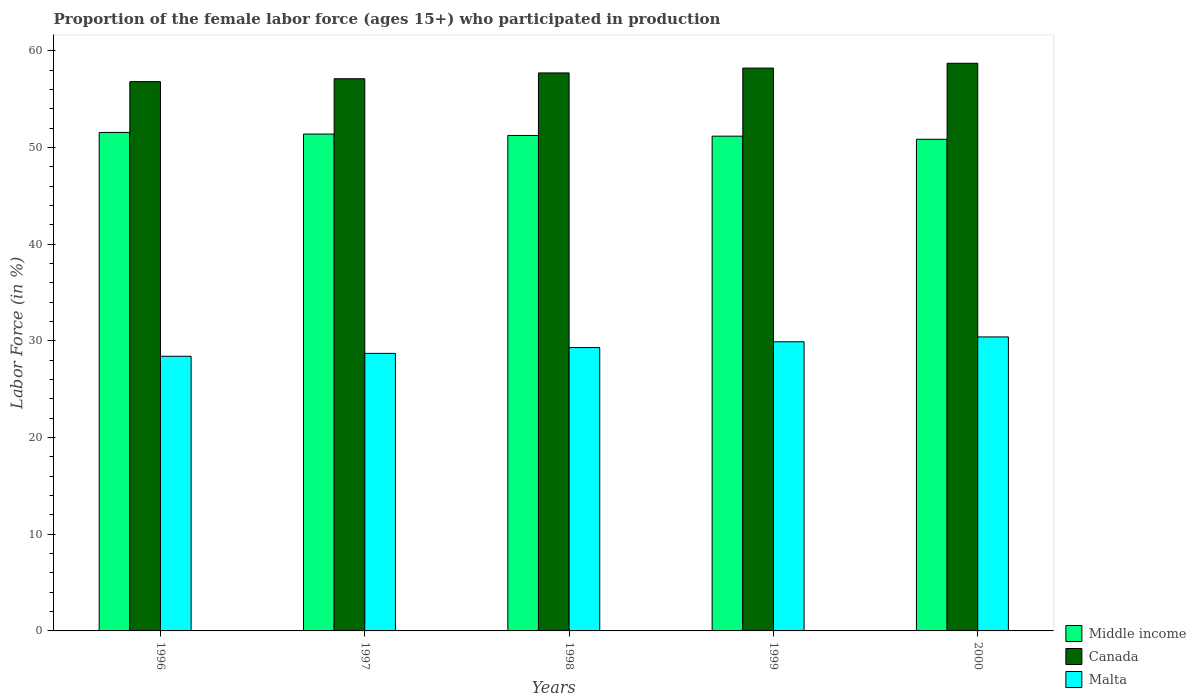Are the number of bars on each tick of the X-axis equal?
Offer a very short reply. Yes. How many bars are there on the 5th tick from the left?
Provide a succinct answer. 3. What is the proportion of the female labor force who participated in production in Middle income in 1997?
Ensure brevity in your answer.  51.38. Across all years, what is the maximum proportion of the female labor force who participated in production in Middle income?
Your answer should be very brief. 51.55. Across all years, what is the minimum proportion of the female labor force who participated in production in Middle income?
Your answer should be very brief. 50.84. In which year was the proportion of the female labor force who participated in production in Malta minimum?
Ensure brevity in your answer.  1996. What is the total proportion of the female labor force who participated in production in Malta in the graph?
Make the answer very short. 146.7. What is the difference between the proportion of the female labor force who participated in production in Canada in 1996 and that in 1999?
Offer a terse response. -1.4. What is the difference between the proportion of the female labor force who participated in production in Middle income in 1997 and the proportion of the female labor force who participated in production in Malta in 1999?
Ensure brevity in your answer.  21.48. What is the average proportion of the female labor force who participated in production in Middle income per year?
Keep it short and to the point. 51.23. In the year 1998, what is the difference between the proportion of the female labor force who participated in production in Middle income and proportion of the female labor force who participated in production in Canada?
Your response must be concise. -6.47. In how many years, is the proportion of the female labor force who participated in production in Canada greater than 36 %?
Ensure brevity in your answer.  5. What is the ratio of the proportion of the female labor force who participated in production in Malta in 1998 to that in 1999?
Ensure brevity in your answer.  0.98. Is the proportion of the female labor force who participated in production in Canada in 1996 less than that in 1998?
Offer a very short reply. Yes. What is the difference between the highest and the second highest proportion of the female labor force who participated in production in Middle income?
Make the answer very short. 0.17. What is the difference between the highest and the lowest proportion of the female labor force who participated in production in Middle income?
Your answer should be very brief. 0.71. In how many years, is the proportion of the female labor force who participated in production in Middle income greater than the average proportion of the female labor force who participated in production in Middle income taken over all years?
Give a very brief answer. 3. What does the 1st bar from the left in 1997 represents?
Your response must be concise. Middle income. What does the 1st bar from the right in 1999 represents?
Your answer should be compact. Malta. How many bars are there?
Offer a terse response. 15. Are the values on the major ticks of Y-axis written in scientific E-notation?
Give a very brief answer. No. Does the graph contain grids?
Offer a very short reply. No. What is the title of the graph?
Your answer should be compact. Proportion of the female labor force (ages 15+) who participated in production. Does "Montenegro" appear as one of the legend labels in the graph?
Keep it short and to the point. No. What is the Labor Force (in %) of Middle income in 1996?
Give a very brief answer. 51.55. What is the Labor Force (in %) of Canada in 1996?
Provide a short and direct response. 56.8. What is the Labor Force (in %) in Malta in 1996?
Give a very brief answer. 28.4. What is the Labor Force (in %) of Middle income in 1997?
Your answer should be compact. 51.38. What is the Labor Force (in %) in Canada in 1997?
Make the answer very short. 57.1. What is the Labor Force (in %) of Malta in 1997?
Your answer should be compact. 28.7. What is the Labor Force (in %) in Middle income in 1998?
Keep it short and to the point. 51.23. What is the Labor Force (in %) of Canada in 1998?
Provide a short and direct response. 57.7. What is the Labor Force (in %) of Malta in 1998?
Make the answer very short. 29.3. What is the Labor Force (in %) in Middle income in 1999?
Ensure brevity in your answer.  51.16. What is the Labor Force (in %) in Canada in 1999?
Give a very brief answer. 58.2. What is the Labor Force (in %) in Malta in 1999?
Offer a very short reply. 29.9. What is the Labor Force (in %) in Middle income in 2000?
Make the answer very short. 50.84. What is the Labor Force (in %) of Canada in 2000?
Provide a short and direct response. 58.7. What is the Labor Force (in %) of Malta in 2000?
Give a very brief answer. 30.4. Across all years, what is the maximum Labor Force (in %) of Middle income?
Your answer should be very brief. 51.55. Across all years, what is the maximum Labor Force (in %) in Canada?
Offer a terse response. 58.7. Across all years, what is the maximum Labor Force (in %) in Malta?
Provide a succinct answer. 30.4. Across all years, what is the minimum Labor Force (in %) of Middle income?
Offer a terse response. 50.84. Across all years, what is the minimum Labor Force (in %) of Canada?
Ensure brevity in your answer.  56.8. Across all years, what is the minimum Labor Force (in %) in Malta?
Offer a very short reply. 28.4. What is the total Labor Force (in %) in Middle income in the graph?
Make the answer very short. 256.16. What is the total Labor Force (in %) in Canada in the graph?
Your response must be concise. 288.5. What is the total Labor Force (in %) of Malta in the graph?
Give a very brief answer. 146.7. What is the difference between the Labor Force (in %) in Middle income in 1996 and that in 1997?
Offer a very short reply. 0.17. What is the difference between the Labor Force (in %) in Canada in 1996 and that in 1997?
Provide a short and direct response. -0.3. What is the difference between the Labor Force (in %) in Malta in 1996 and that in 1997?
Offer a terse response. -0.3. What is the difference between the Labor Force (in %) of Middle income in 1996 and that in 1998?
Offer a terse response. 0.31. What is the difference between the Labor Force (in %) in Canada in 1996 and that in 1998?
Your response must be concise. -0.9. What is the difference between the Labor Force (in %) of Middle income in 1996 and that in 1999?
Your answer should be very brief. 0.39. What is the difference between the Labor Force (in %) in Malta in 1996 and that in 1999?
Offer a terse response. -1.5. What is the difference between the Labor Force (in %) in Middle income in 1996 and that in 2000?
Give a very brief answer. 0.71. What is the difference between the Labor Force (in %) of Canada in 1996 and that in 2000?
Keep it short and to the point. -1.9. What is the difference between the Labor Force (in %) of Malta in 1996 and that in 2000?
Your response must be concise. -2. What is the difference between the Labor Force (in %) of Middle income in 1997 and that in 1998?
Make the answer very short. 0.15. What is the difference between the Labor Force (in %) in Malta in 1997 and that in 1998?
Your answer should be very brief. -0.6. What is the difference between the Labor Force (in %) of Middle income in 1997 and that in 1999?
Provide a succinct answer. 0.22. What is the difference between the Labor Force (in %) of Middle income in 1997 and that in 2000?
Your answer should be compact. 0.54. What is the difference between the Labor Force (in %) in Canada in 1997 and that in 2000?
Your answer should be very brief. -1.6. What is the difference between the Labor Force (in %) of Middle income in 1998 and that in 1999?
Ensure brevity in your answer.  0.07. What is the difference between the Labor Force (in %) in Canada in 1998 and that in 1999?
Your response must be concise. -0.5. What is the difference between the Labor Force (in %) of Malta in 1998 and that in 1999?
Make the answer very short. -0.6. What is the difference between the Labor Force (in %) in Middle income in 1998 and that in 2000?
Your response must be concise. 0.39. What is the difference between the Labor Force (in %) in Canada in 1998 and that in 2000?
Offer a terse response. -1. What is the difference between the Labor Force (in %) in Middle income in 1999 and that in 2000?
Your answer should be very brief. 0.32. What is the difference between the Labor Force (in %) in Canada in 1999 and that in 2000?
Give a very brief answer. -0.5. What is the difference between the Labor Force (in %) of Malta in 1999 and that in 2000?
Your answer should be very brief. -0.5. What is the difference between the Labor Force (in %) in Middle income in 1996 and the Labor Force (in %) in Canada in 1997?
Your answer should be very brief. -5.55. What is the difference between the Labor Force (in %) of Middle income in 1996 and the Labor Force (in %) of Malta in 1997?
Give a very brief answer. 22.85. What is the difference between the Labor Force (in %) of Canada in 1996 and the Labor Force (in %) of Malta in 1997?
Provide a short and direct response. 28.1. What is the difference between the Labor Force (in %) of Middle income in 1996 and the Labor Force (in %) of Canada in 1998?
Your answer should be compact. -6.15. What is the difference between the Labor Force (in %) of Middle income in 1996 and the Labor Force (in %) of Malta in 1998?
Your answer should be compact. 22.25. What is the difference between the Labor Force (in %) of Canada in 1996 and the Labor Force (in %) of Malta in 1998?
Keep it short and to the point. 27.5. What is the difference between the Labor Force (in %) in Middle income in 1996 and the Labor Force (in %) in Canada in 1999?
Provide a succinct answer. -6.65. What is the difference between the Labor Force (in %) of Middle income in 1996 and the Labor Force (in %) of Malta in 1999?
Make the answer very short. 21.65. What is the difference between the Labor Force (in %) of Canada in 1996 and the Labor Force (in %) of Malta in 1999?
Keep it short and to the point. 26.9. What is the difference between the Labor Force (in %) in Middle income in 1996 and the Labor Force (in %) in Canada in 2000?
Your response must be concise. -7.15. What is the difference between the Labor Force (in %) in Middle income in 1996 and the Labor Force (in %) in Malta in 2000?
Ensure brevity in your answer.  21.15. What is the difference between the Labor Force (in %) in Canada in 1996 and the Labor Force (in %) in Malta in 2000?
Make the answer very short. 26.4. What is the difference between the Labor Force (in %) in Middle income in 1997 and the Labor Force (in %) in Canada in 1998?
Your response must be concise. -6.32. What is the difference between the Labor Force (in %) of Middle income in 1997 and the Labor Force (in %) of Malta in 1998?
Your answer should be compact. 22.08. What is the difference between the Labor Force (in %) in Canada in 1997 and the Labor Force (in %) in Malta in 1998?
Offer a terse response. 27.8. What is the difference between the Labor Force (in %) in Middle income in 1997 and the Labor Force (in %) in Canada in 1999?
Your answer should be compact. -6.82. What is the difference between the Labor Force (in %) in Middle income in 1997 and the Labor Force (in %) in Malta in 1999?
Offer a terse response. 21.48. What is the difference between the Labor Force (in %) in Canada in 1997 and the Labor Force (in %) in Malta in 1999?
Your answer should be compact. 27.2. What is the difference between the Labor Force (in %) of Middle income in 1997 and the Labor Force (in %) of Canada in 2000?
Make the answer very short. -7.32. What is the difference between the Labor Force (in %) of Middle income in 1997 and the Labor Force (in %) of Malta in 2000?
Your answer should be very brief. 20.98. What is the difference between the Labor Force (in %) of Canada in 1997 and the Labor Force (in %) of Malta in 2000?
Provide a succinct answer. 26.7. What is the difference between the Labor Force (in %) of Middle income in 1998 and the Labor Force (in %) of Canada in 1999?
Offer a terse response. -6.97. What is the difference between the Labor Force (in %) in Middle income in 1998 and the Labor Force (in %) in Malta in 1999?
Keep it short and to the point. 21.33. What is the difference between the Labor Force (in %) in Canada in 1998 and the Labor Force (in %) in Malta in 1999?
Your response must be concise. 27.8. What is the difference between the Labor Force (in %) of Middle income in 1998 and the Labor Force (in %) of Canada in 2000?
Provide a succinct answer. -7.47. What is the difference between the Labor Force (in %) of Middle income in 1998 and the Labor Force (in %) of Malta in 2000?
Offer a very short reply. 20.83. What is the difference between the Labor Force (in %) of Canada in 1998 and the Labor Force (in %) of Malta in 2000?
Offer a terse response. 27.3. What is the difference between the Labor Force (in %) of Middle income in 1999 and the Labor Force (in %) of Canada in 2000?
Make the answer very short. -7.54. What is the difference between the Labor Force (in %) in Middle income in 1999 and the Labor Force (in %) in Malta in 2000?
Provide a succinct answer. 20.76. What is the difference between the Labor Force (in %) of Canada in 1999 and the Labor Force (in %) of Malta in 2000?
Your answer should be very brief. 27.8. What is the average Labor Force (in %) of Middle income per year?
Provide a succinct answer. 51.23. What is the average Labor Force (in %) of Canada per year?
Make the answer very short. 57.7. What is the average Labor Force (in %) in Malta per year?
Provide a short and direct response. 29.34. In the year 1996, what is the difference between the Labor Force (in %) in Middle income and Labor Force (in %) in Canada?
Give a very brief answer. -5.25. In the year 1996, what is the difference between the Labor Force (in %) of Middle income and Labor Force (in %) of Malta?
Make the answer very short. 23.15. In the year 1996, what is the difference between the Labor Force (in %) of Canada and Labor Force (in %) of Malta?
Your answer should be compact. 28.4. In the year 1997, what is the difference between the Labor Force (in %) in Middle income and Labor Force (in %) in Canada?
Provide a succinct answer. -5.72. In the year 1997, what is the difference between the Labor Force (in %) in Middle income and Labor Force (in %) in Malta?
Make the answer very short. 22.68. In the year 1997, what is the difference between the Labor Force (in %) of Canada and Labor Force (in %) of Malta?
Make the answer very short. 28.4. In the year 1998, what is the difference between the Labor Force (in %) of Middle income and Labor Force (in %) of Canada?
Offer a terse response. -6.47. In the year 1998, what is the difference between the Labor Force (in %) of Middle income and Labor Force (in %) of Malta?
Your answer should be compact. 21.93. In the year 1998, what is the difference between the Labor Force (in %) in Canada and Labor Force (in %) in Malta?
Provide a succinct answer. 28.4. In the year 1999, what is the difference between the Labor Force (in %) in Middle income and Labor Force (in %) in Canada?
Offer a very short reply. -7.04. In the year 1999, what is the difference between the Labor Force (in %) in Middle income and Labor Force (in %) in Malta?
Provide a succinct answer. 21.26. In the year 1999, what is the difference between the Labor Force (in %) in Canada and Labor Force (in %) in Malta?
Keep it short and to the point. 28.3. In the year 2000, what is the difference between the Labor Force (in %) in Middle income and Labor Force (in %) in Canada?
Your answer should be compact. -7.86. In the year 2000, what is the difference between the Labor Force (in %) of Middle income and Labor Force (in %) of Malta?
Your answer should be very brief. 20.44. In the year 2000, what is the difference between the Labor Force (in %) of Canada and Labor Force (in %) of Malta?
Keep it short and to the point. 28.3. What is the ratio of the Labor Force (in %) of Canada in 1996 to that in 1998?
Ensure brevity in your answer.  0.98. What is the ratio of the Labor Force (in %) in Malta in 1996 to that in 1998?
Make the answer very short. 0.97. What is the ratio of the Labor Force (in %) in Middle income in 1996 to that in 1999?
Give a very brief answer. 1.01. What is the ratio of the Labor Force (in %) of Canada in 1996 to that in 1999?
Offer a very short reply. 0.98. What is the ratio of the Labor Force (in %) in Malta in 1996 to that in 1999?
Your answer should be very brief. 0.95. What is the ratio of the Labor Force (in %) of Middle income in 1996 to that in 2000?
Offer a terse response. 1.01. What is the ratio of the Labor Force (in %) of Canada in 1996 to that in 2000?
Make the answer very short. 0.97. What is the ratio of the Labor Force (in %) in Malta in 1996 to that in 2000?
Your answer should be compact. 0.93. What is the ratio of the Labor Force (in %) in Canada in 1997 to that in 1998?
Offer a terse response. 0.99. What is the ratio of the Labor Force (in %) in Malta in 1997 to that in 1998?
Offer a very short reply. 0.98. What is the ratio of the Labor Force (in %) of Middle income in 1997 to that in 1999?
Keep it short and to the point. 1. What is the ratio of the Labor Force (in %) of Canada in 1997 to that in 1999?
Your answer should be compact. 0.98. What is the ratio of the Labor Force (in %) in Malta in 1997 to that in 1999?
Your response must be concise. 0.96. What is the ratio of the Labor Force (in %) in Middle income in 1997 to that in 2000?
Make the answer very short. 1.01. What is the ratio of the Labor Force (in %) in Canada in 1997 to that in 2000?
Make the answer very short. 0.97. What is the ratio of the Labor Force (in %) of Malta in 1997 to that in 2000?
Ensure brevity in your answer.  0.94. What is the ratio of the Labor Force (in %) of Middle income in 1998 to that in 1999?
Offer a very short reply. 1. What is the ratio of the Labor Force (in %) of Malta in 1998 to that in 1999?
Your answer should be very brief. 0.98. What is the ratio of the Labor Force (in %) of Middle income in 1998 to that in 2000?
Give a very brief answer. 1.01. What is the ratio of the Labor Force (in %) of Malta in 1998 to that in 2000?
Provide a short and direct response. 0.96. What is the ratio of the Labor Force (in %) in Middle income in 1999 to that in 2000?
Offer a very short reply. 1.01. What is the ratio of the Labor Force (in %) in Malta in 1999 to that in 2000?
Your answer should be very brief. 0.98. What is the difference between the highest and the second highest Labor Force (in %) in Middle income?
Ensure brevity in your answer.  0.17. What is the difference between the highest and the lowest Labor Force (in %) of Middle income?
Your answer should be compact. 0.71. 